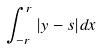<formula> <loc_0><loc_0><loc_500><loc_500>\int _ { - r } ^ { r } | y - s | d x</formula> 